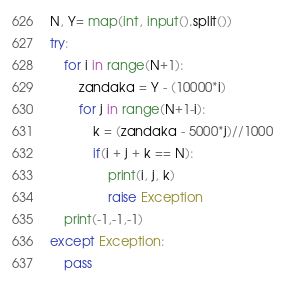Convert code to text. <code><loc_0><loc_0><loc_500><loc_500><_Python_>N, Y= map(int, input().split())
try:	
	for i in range(N+1):
		zandaka = Y - (10000*i)
		for j in range(N+1-i):
			k = (zandaka - 5000*j)//1000
			if(i + j + k == N):
				print(i, j, k)
				raise Exception
	print(-1,-1,-1)
except Exception:
	pass</code> 